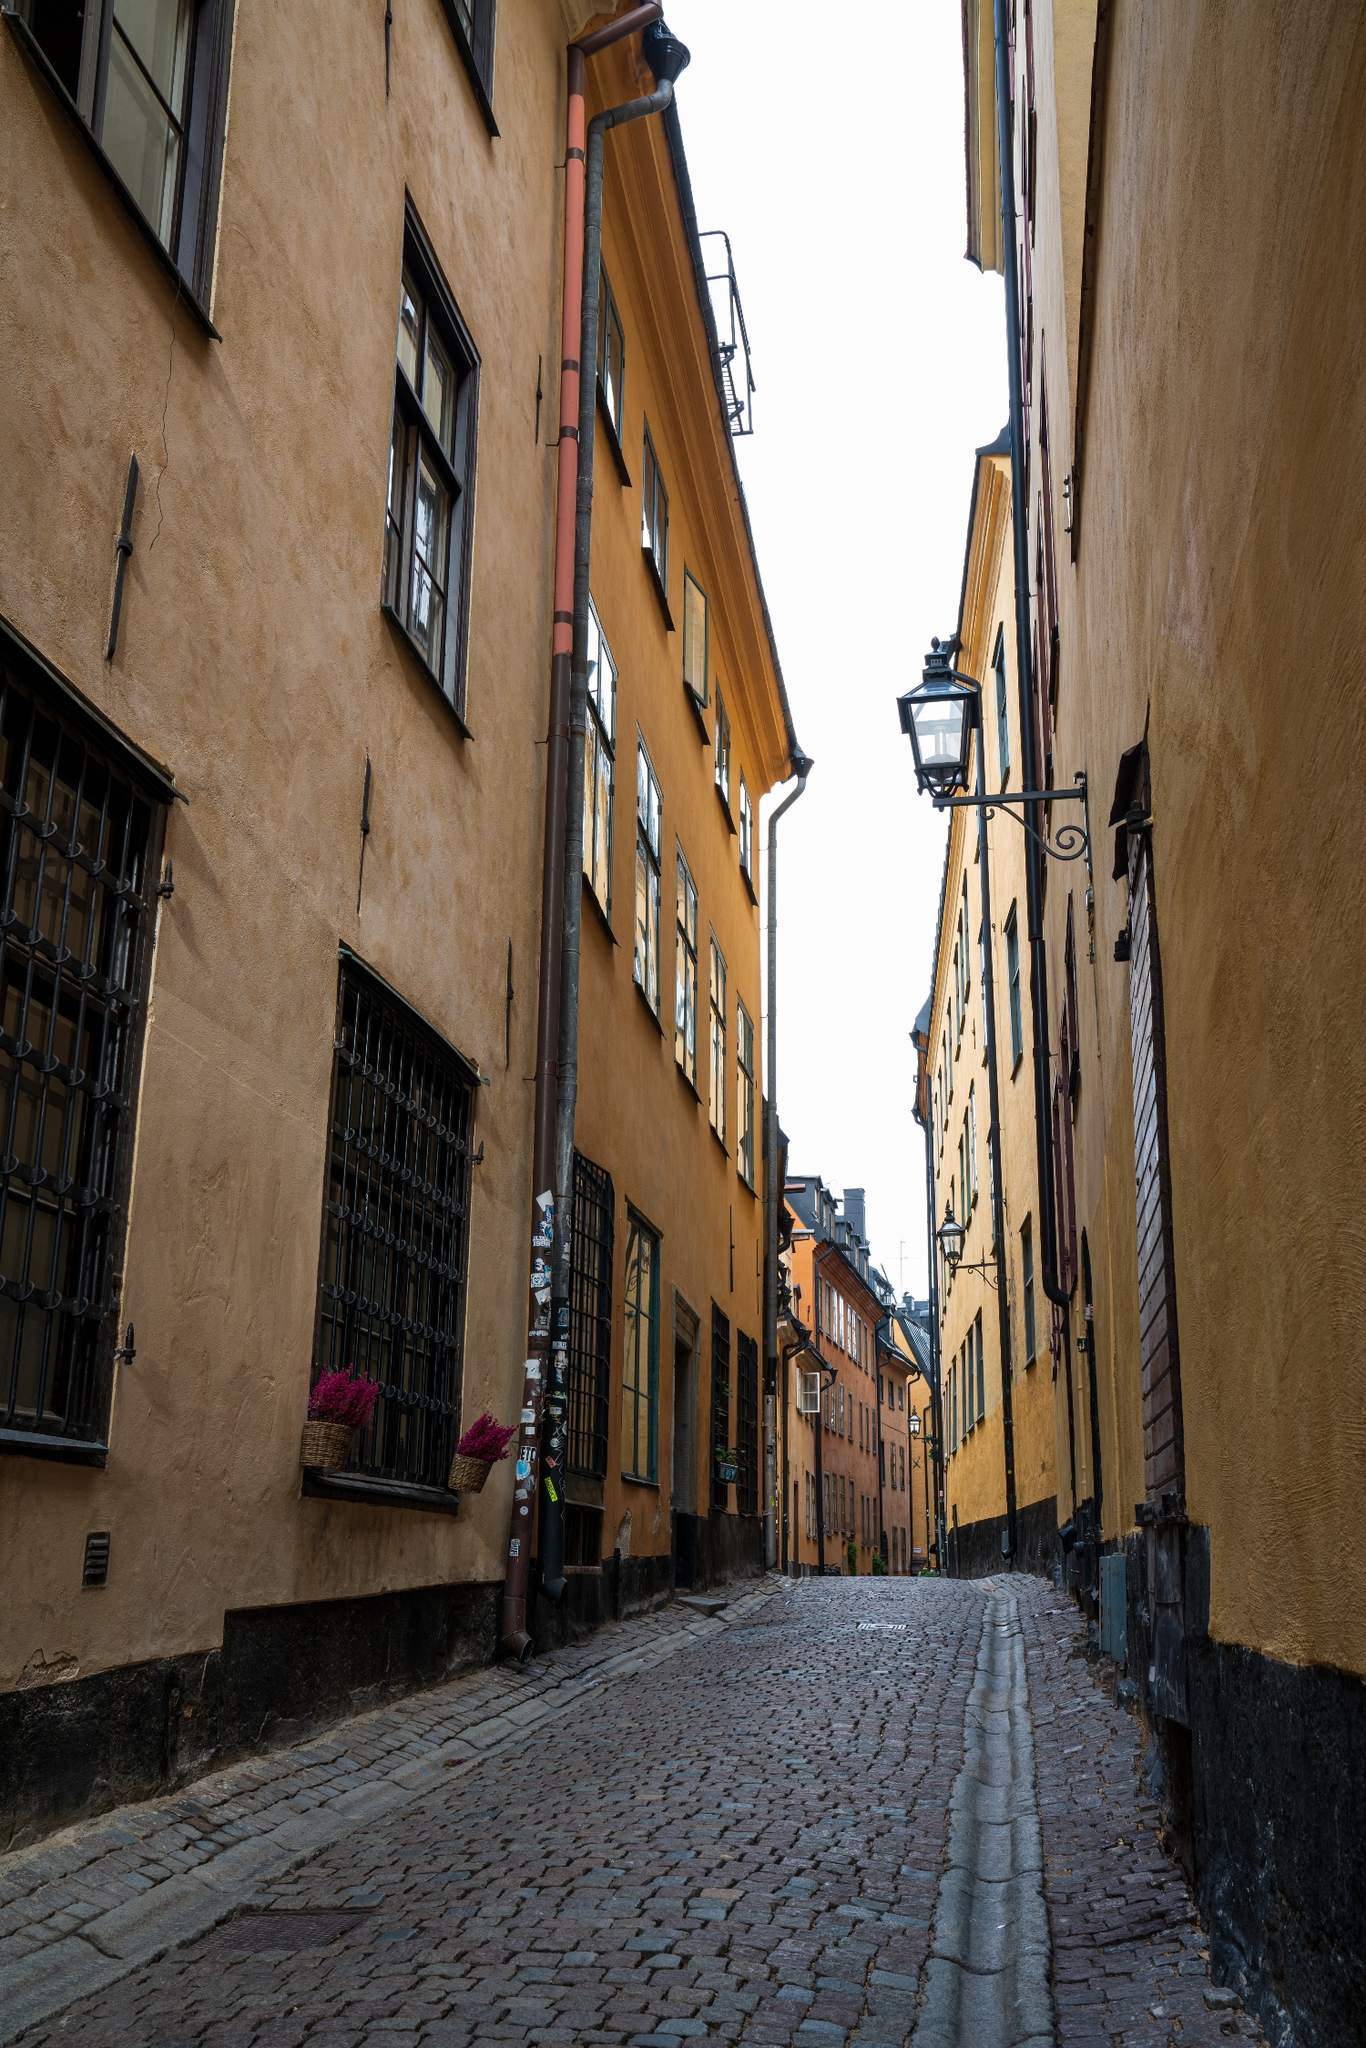What might be a typical day like for residents of this street? Residents of this street likely experience a blend of historic charm and modern living. The narrowness suggests limited vehicular traffic, making it a quiet, pedestrian-friendly area. Locals might start their day by opening the shutters to let in light, perhaps tending to flowers in the boxes outside their windows. Daily routines could involve frequenting small, nearby cafes or boutiques, creating a tight-knit community atmosphere centered around neighborhood interactions. 